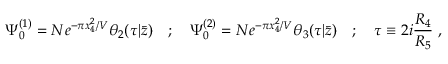Convert formula to latex. <formula><loc_0><loc_0><loc_500><loc_500>\Psi _ { 0 } ^ { ( 1 ) } = N e ^ { - \pi x _ { 4 } ^ { 2 } / V } \theta _ { 2 } ( \tau | \bar { z } ) \quad ; \quad \Psi _ { 0 } ^ { ( 2 ) } = N e ^ { - \pi x _ { 4 } ^ { 2 } / V } \theta _ { 3 } ( \tau | \bar { z } ) \quad ; \quad \tau \equiv 2 i { \frac { R _ { 4 } } { R _ { 5 } } } \ ,</formula> 